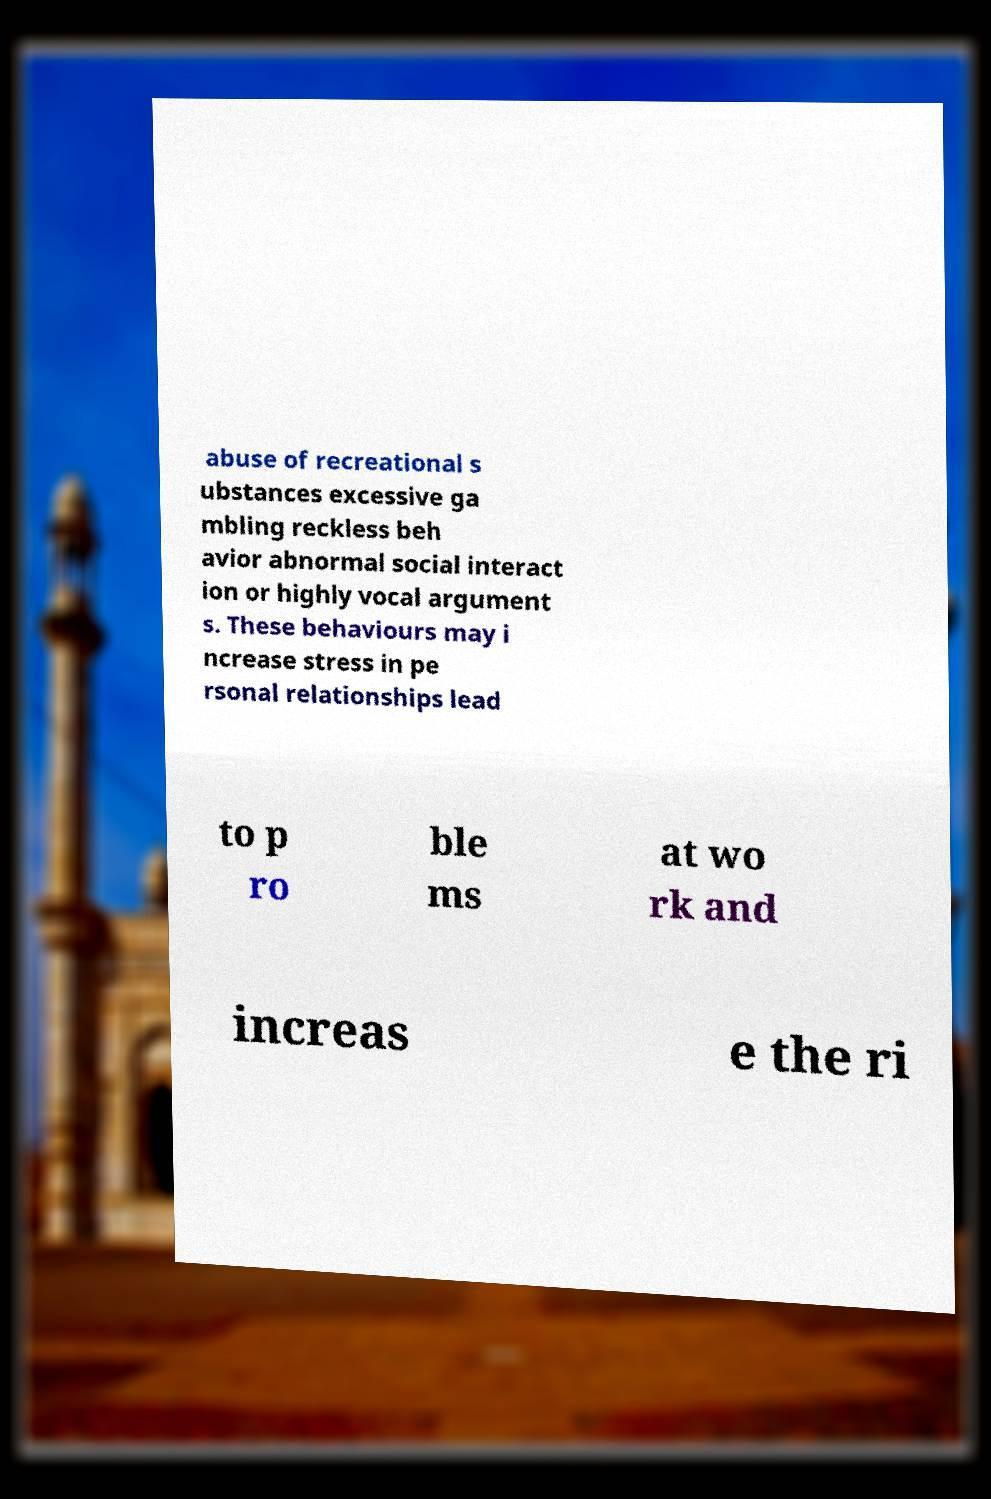Could you extract and type out the text from this image? abuse of recreational s ubstances excessive ga mbling reckless beh avior abnormal social interact ion or highly vocal argument s. These behaviours may i ncrease stress in pe rsonal relationships lead to p ro ble ms at wo rk and increas e the ri 